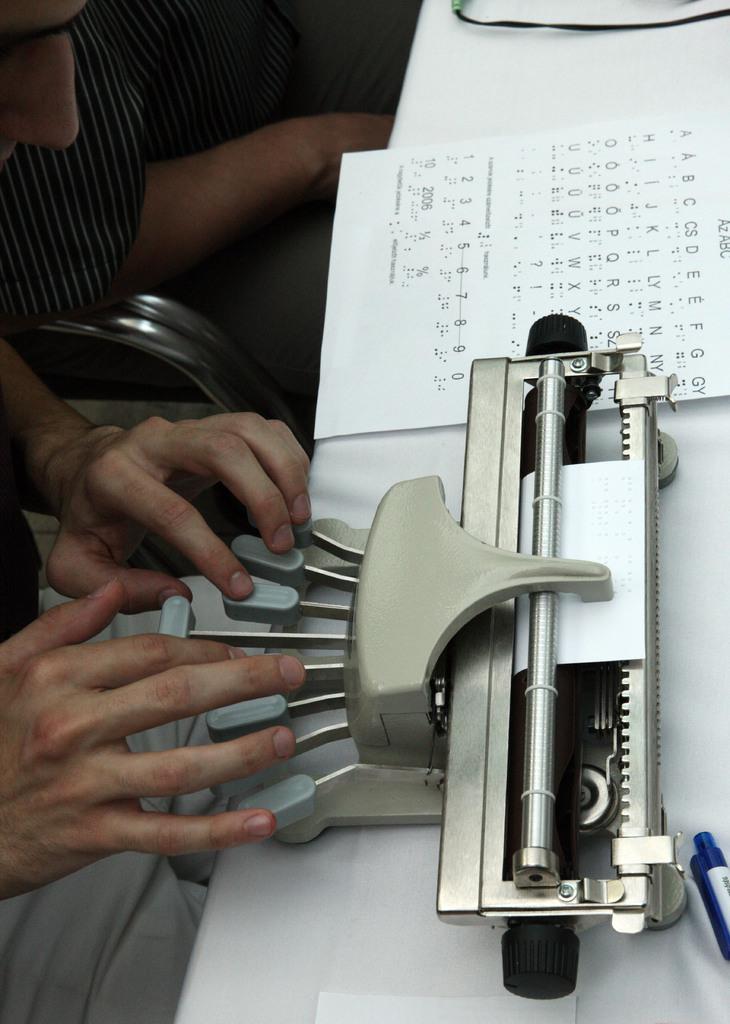In one or two sentences, can you explain what this image depicts? In this image there is a table and we can see a typing machine, paper and a pen placed on the table. On the left there are people sitting. The man sitting in the front is typing. 